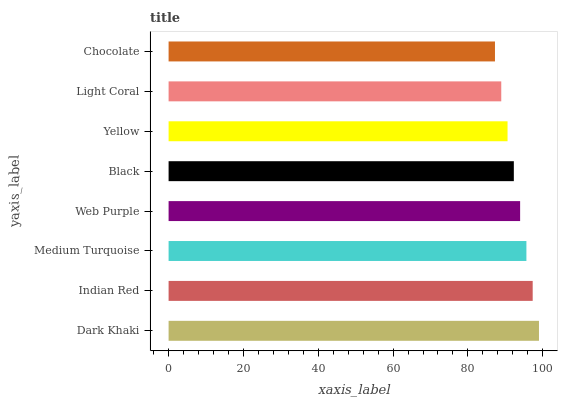Is Chocolate the minimum?
Answer yes or no. Yes. Is Dark Khaki the maximum?
Answer yes or no. Yes. Is Indian Red the minimum?
Answer yes or no. No. Is Indian Red the maximum?
Answer yes or no. No. Is Dark Khaki greater than Indian Red?
Answer yes or no. Yes. Is Indian Red less than Dark Khaki?
Answer yes or no. Yes. Is Indian Red greater than Dark Khaki?
Answer yes or no. No. Is Dark Khaki less than Indian Red?
Answer yes or no. No. Is Web Purple the high median?
Answer yes or no. Yes. Is Black the low median?
Answer yes or no. Yes. Is Indian Red the high median?
Answer yes or no. No. Is Dark Khaki the low median?
Answer yes or no. No. 